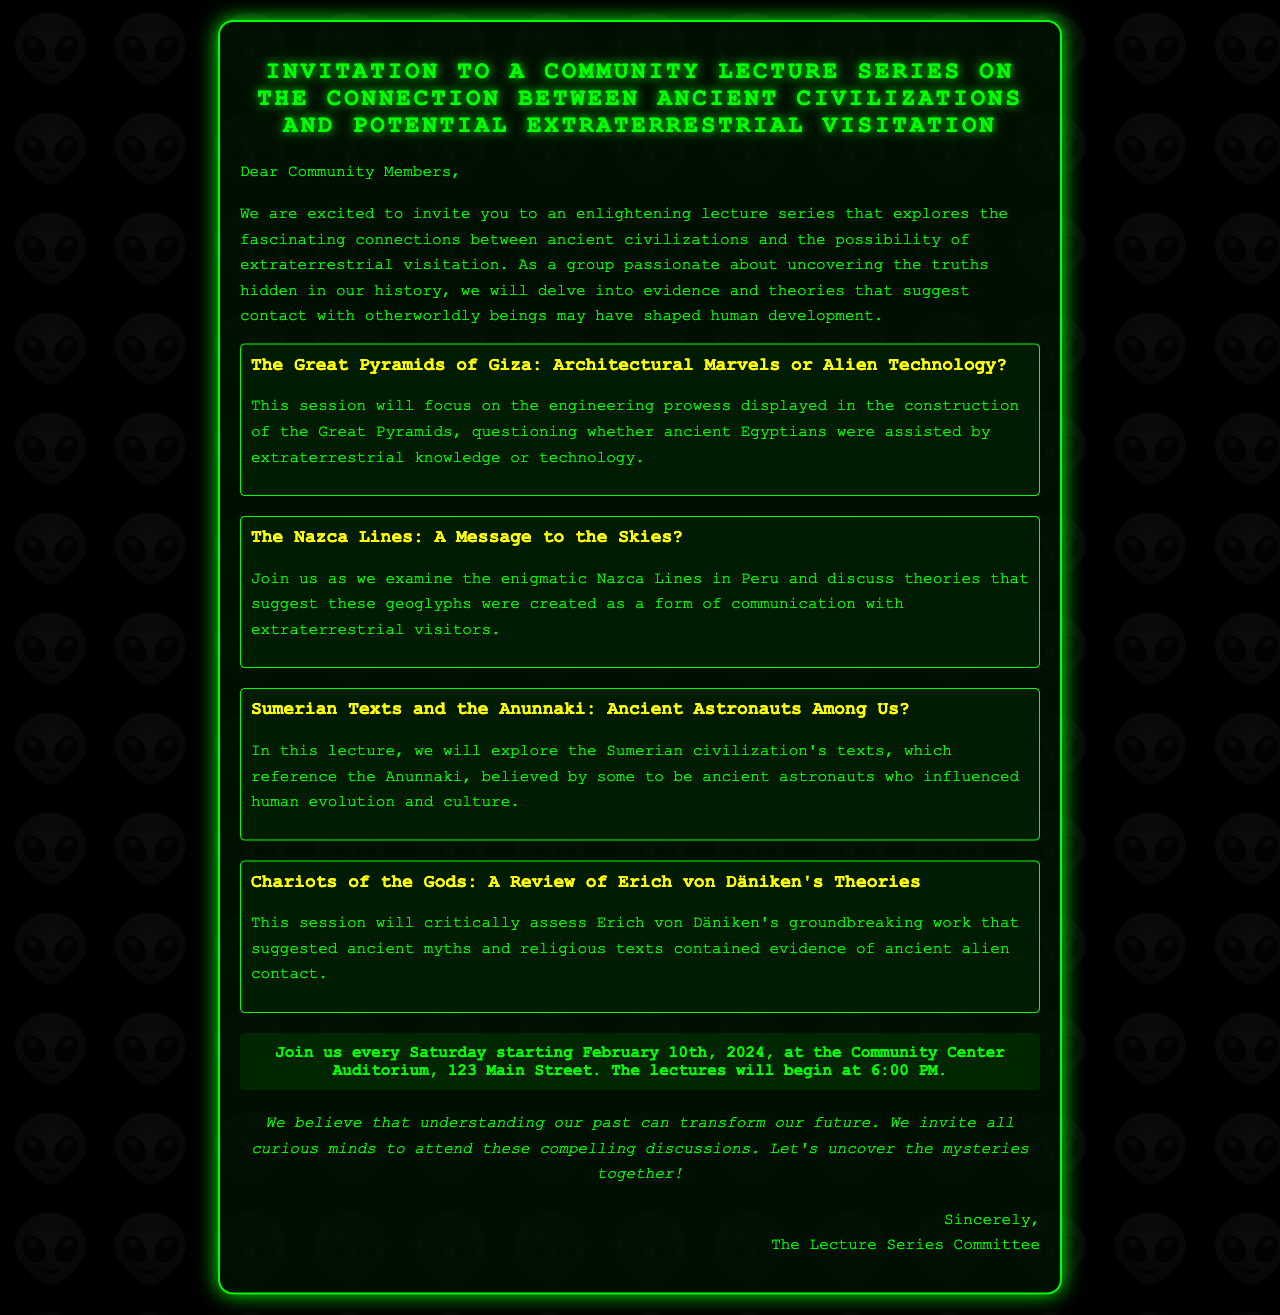What is the title of the lecture series? The title of the lecture series is stated prominently at the beginning of the document.
Answer: Invitation to a Community Lecture Series on the Connection Between Ancient Civilizations and Potential Extraterrestrial Visitation When does the lecture series start? The document provides a specific starting date in the date-location section.
Answer: February 10th, 2024 Where will the lectures be held? The location of the lectures is clearly mentioned in the date-location section of the document.
Answer: Community Center Auditorium, 123 Main Street What time do the lectures begin? The document specifies the starting time for the lecture series in the date-location section.
Answer: 6:00 PM Who is the author of the invitation? The author or the signatory of the document is identified at the end of the letter.
Answer: The Lecture Series Committee What is the main focus of the lecture about Sumerian texts? The topic is clearly outlined in the respective lecture description provided in the document.
Answer: Anunnaki: Ancient Astronauts Among Us? How often will the lectures occur? The regularity of the lectures is mentioned in the date-location section, indicating a weekly pattern.
Answer: Every Saturday What is one of the subjects discussed related to the Nazca Lines? The subject matter for the Nazca Lines lecture is outlined in its description in the document.
Answer: Communication with extraterrestrial visitors What is the purpose of the lecture series? The intention or purpose of the lecture series is expressed in the introductory paragraph.
Answer: To explore connections between ancient civilizations and extraterrestrial visitation 